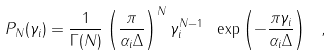<formula> <loc_0><loc_0><loc_500><loc_500>P _ { N } ( \gamma _ { i } ) = \frac { 1 } { \Gamma ( N ) } \left ( \frac { \pi } { \alpha _ { i } \Delta } \right ) ^ { N } \gamma _ { i } ^ { N - 1 } \ \exp \left ( - \frac { \pi \gamma _ { i } } { \alpha _ { i } \Delta } \right ) \ ,</formula> 